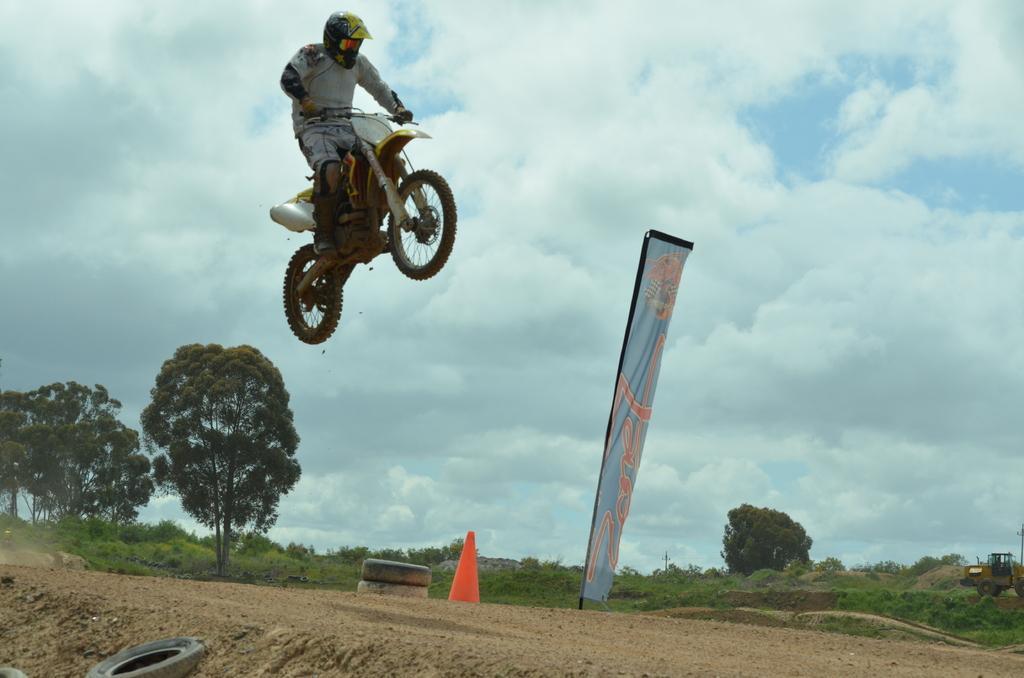In one or two sentences, can you explain what this image depicts? This picture is clicked outside the city. In the foreground we can see the tires and some other items are placed on the ground. At the top there is a person in the air with the bike. In the background we can see the sky which is full of clouds and we can see the green grass, plants, trees and a vehicle. 